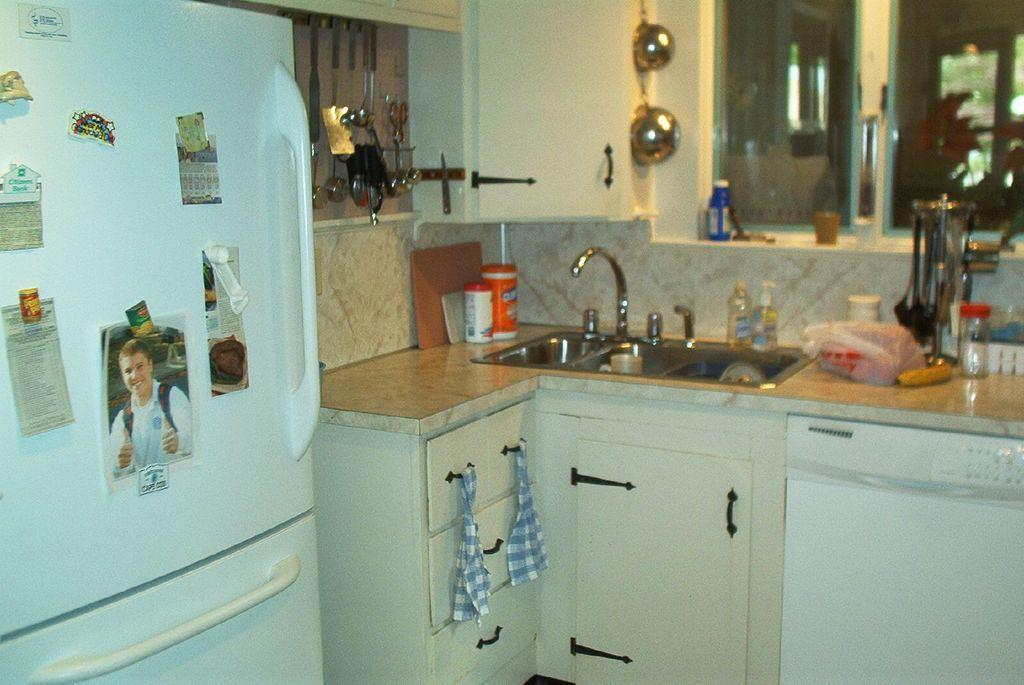What type of room is depicted in the image? The image appears to depict a kitchen. What appliance can be seen on the left side of the image? There is a refrigerator in white color on the left side. What is located in the middle of the image? In the middle of the image, there is a tap and a sink. What items are used for cooking or eating in the image? Utensils are present in the image. Can you describe the rainstorm happening outside the window in the image? There is no window or rainstorm visible in the image; it depicts a kitchen with a refrigerator, tap and sink, and utensils. What type of jar is sitting on the counter next to the refrigerator in the image? There is no jar present in the image; it only shows a refrigerator, tap and sink, and utensils. 